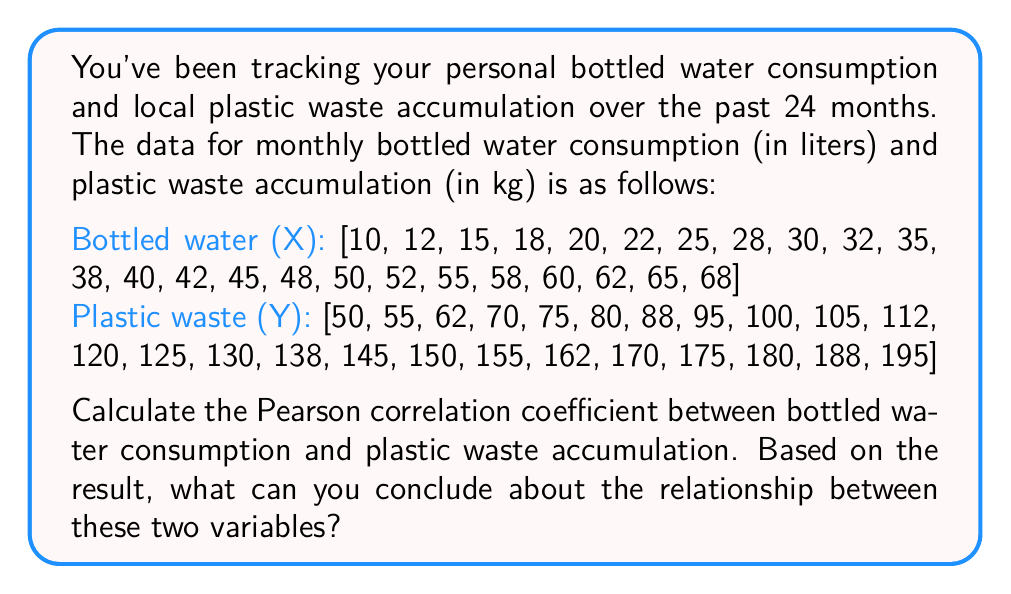Give your solution to this math problem. To calculate the Pearson correlation coefficient, we'll use the formula:

$$ r = \frac{\sum_{i=1}^{n} (x_i - \bar{x})(y_i - \bar{y})}{\sqrt{\sum_{i=1}^{n} (x_i - \bar{x})^2} \sqrt{\sum_{i=1}^{n} (y_i - \bar{y})^2}} $$

Where:
$r$ is the Pearson correlation coefficient
$x_i$ and $y_i$ are the individual sample points
$\bar{x}$ and $\bar{y}$ are the sample means

Step 1: Calculate the means
$\bar{x} = \frac{\sum_{i=1}^{n} x_i}{n} = \frac{878}{24} = 36.5833$
$\bar{y} = \frac{\sum_{i=1}^{n} y_i}{n} = \frac{2930}{24} = 122.0833$

Step 2: Calculate $(x_i - \bar{x})$, $(y_i - \bar{y})$, $(x_i - \bar{x})^2$, $(y_i - \bar{y})^2$, and $(x_i - \bar{x})(y_i - \bar{y})$ for each data point.

Step 3: Sum up the values calculated in Step 2
$\sum_{i=1}^{n} (x_i - \bar{x})(y_i - \bar{y}) = 13,104.1667$
$\sum_{i=1}^{n} (x_i - \bar{x})^2 = 5,425.8333$
$\sum_{i=1}^{n} (y_i - \bar{y})^2 = 31,704.1667$

Step 4: Apply the formula
$$ r = \frac{13,104.1667}{\sqrt{5,425.8333} \sqrt{31,704.1667}} = 0.9992 $$

The Pearson correlation coefficient is approximately 0.9992.

Interpretation:
- The correlation coefficient ranges from -1 to 1.
- A value close to 1 indicates a strong positive correlation.
- In this case, 0.9992 is extremely close to 1, suggesting a very strong positive correlation between bottled water consumption and plastic waste accumulation.
Answer: The Pearson correlation coefficient is approximately 0.9992, indicating a very strong positive correlation between bottled water consumption and plastic waste accumulation. This suggests that as bottled water consumption increases, plastic waste accumulation also increases at a highly consistent rate. 